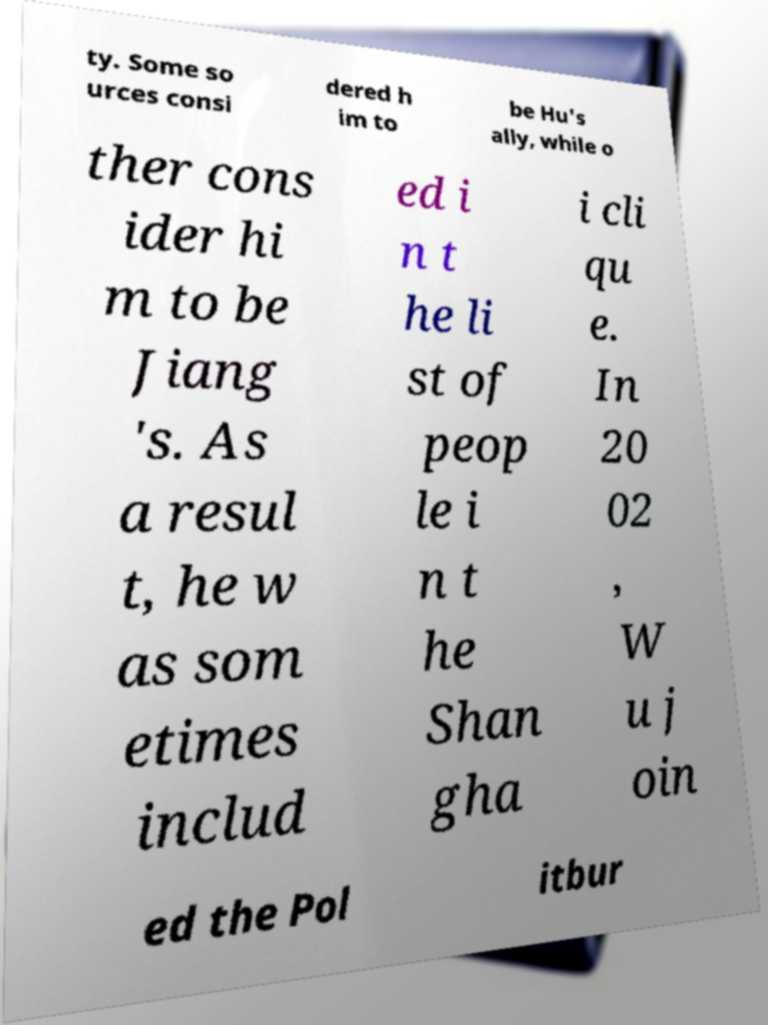What messages or text are displayed in this image? I need them in a readable, typed format. ty. Some so urces consi dered h im to be Hu's ally, while o ther cons ider hi m to be Jiang 's. As a resul t, he w as som etimes includ ed i n t he li st of peop le i n t he Shan gha i cli qu e. In 20 02 , W u j oin ed the Pol itbur 